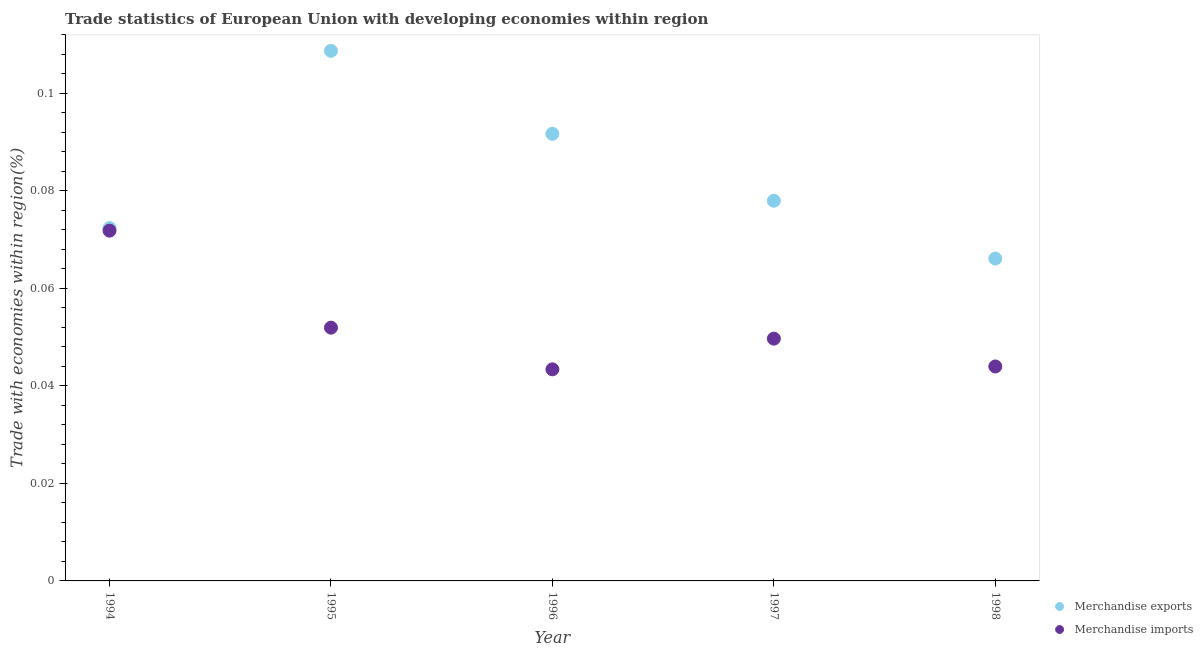How many different coloured dotlines are there?
Your answer should be compact. 2. Is the number of dotlines equal to the number of legend labels?
Your response must be concise. Yes. What is the merchandise exports in 1997?
Provide a short and direct response. 0.08. Across all years, what is the maximum merchandise imports?
Offer a terse response. 0.07. Across all years, what is the minimum merchandise imports?
Offer a very short reply. 0.04. In which year was the merchandise imports maximum?
Give a very brief answer. 1994. What is the total merchandise exports in the graph?
Your response must be concise. 0.42. What is the difference between the merchandise imports in 1997 and that in 1998?
Offer a terse response. 0.01. What is the difference between the merchandise imports in 1994 and the merchandise exports in 1996?
Your answer should be compact. -0.02. What is the average merchandise exports per year?
Offer a very short reply. 0.08. In the year 1997, what is the difference between the merchandise imports and merchandise exports?
Offer a very short reply. -0.03. In how many years, is the merchandise imports greater than 0.048 %?
Your answer should be very brief. 3. What is the ratio of the merchandise exports in 1994 to that in 1998?
Your answer should be very brief. 1.09. Is the difference between the merchandise exports in 1994 and 1997 greater than the difference between the merchandise imports in 1994 and 1997?
Keep it short and to the point. No. What is the difference between the highest and the second highest merchandise imports?
Your answer should be compact. 0.02. What is the difference between the highest and the lowest merchandise imports?
Keep it short and to the point. 0.03. Is the sum of the merchandise imports in 1994 and 1995 greater than the maximum merchandise exports across all years?
Make the answer very short. Yes. How many dotlines are there?
Give a very brief answer. 2. How many years are there in the graph?
Make the answer very short. 5. Does the graph contain any zero values?
Your answer should be very brief. No. Does the graph contain grids?
Ensure brevity in your answer.  No. Where does the legend appear in the graph?
Provide a succinct answer. Bottom right. How are the legend labels stacked?
Offer a terse response. Vertical. What is the title of the graph?
Keep it short and to the point. Trade statistics of European Union with developing economies within region. Does "Depositors" appear as one of the legend labels in the graph?
Your answer should be compact. No. What is the label or title of the X-axis?
Provide a short and direct response. Year. What is the label or title of the Y-axis?
Offer a terse response. Trade with economies within region(%). What is the Trade with economies within region(%) in Merchandise exports in 1994?
Ensure brevity in your answer.  0.07. What is the Trade with economies within region(%) in Merchandise imports in 1994?
Give a very brief answer. 0.07. What is the Trade with economies within region(%) in Merchandise exports in 1995?
Your answer should be compact. 0.11. What is the Trade with economies within region(%) of Merchandise imports in 1995?
Provide a succinct answer. 0.05. What is the Trade with economies within region(%) of Merchandise exports in 1996?
Provide a succinct answer. 0.09. What is the Trade with economies within region(%) of Merchandise imports in 1996?
Keep it short and to the point. 0.04. What is the Trade with economies within region(%) of Merchandise exports in 1997?
Give a very brief answer. 0.08. What is the Trade with economies within region(%) in Merchandise imports in 1997?
Offer a terse response. 0.05. What is the Trade with economies within region(%) of Merchandise exports in 1998?
Offer a terse response. 0.07. What is the Trade with economies within region(%) in Merchandise imports in 1998?
Give a very brief answer. 0.04. Across all years, what is the maximum Trade with economies within region(%) of Merchandise exports?
Offer a terse response. 0.11. Across all years, what is the maximum Trade with economies within region(%) in Merchandise imports?
Provide a short and direct response. 0.07. Across all years, what is the minimum Trade with economies within region(%) of Merchandise exports?
Your answer should be very brief. 0.07. Across all years, what is the minimum Trade with economies within region(%) of Merchandise imports?
Provide a succinct answer. 0.04. What is the total Trade with economies within region(%) in Merchandise exports in the graph?
Provide a succinct answer. 0.42. What is the total Trade with economies within region(%) of Merchandise imports in the graph?
Your answer should be compact. 0.26. What is the difference between the Trade with economies within region(%) in Merchandise exports in 1994 and that in 1995?
Offer a very short reply. -0.04. What is the difference between the Trade with economies within region(%) in Merchandise imports in 1994 and that in 1995?
Offer a very short reply. 0.02. What is the difference between the Trade with economies within region(%) of Merchandise exports in 1994 and that in 1996?
Offer a terse response. -0.02. What is the difference between the Trade with economies within region(%) of Merchandise imports in 1994 and that in 1996?
Your answer should be compact. 0.03. What is the difference between the Trade with economies within region(%) in Merchandise exports in 1994 and that in 1997?
Provide a short and direct response. -0.01. What is the difference between the Trade with economies within region(%) in Merchandise imports in 1994 and that in 1997?
Provide a succinct answer. 0.02. What is the difference between the Trade with economies within region(%) of Merchandise exports in 1994 and that in 1998?
Your response must be concise. 0.01. What is the difference between the Trade with economies within region(%) in Merchandise imports in 1994 and that in 1998?
Your response must be concise. 0.03. What is the difference between the Trade with economies within region(%) of Merchandise exports in 1995 and that in 1996?
Your answer should be very brief. 0.02. What is the difference between the Trade with economies within region(%) in Merchandise imports in 1995 and that in 1996?
Your answer should be very brief. 0.01. What is the difference between the Trade with economies within region(%) of Merchandise exports in 1995 and that in 1997?
Your response must be concise. 0.03. What is the difference between the Trade with economies within region(%) in Merchandise imports in 1995 and that in 1997?
Keep it short and to the point. 0. What is the difference between the Trade with economies within region(%) of Merchandise exports in 1995 and that in 1998?
Give a very brief answer. 0.04. What is the difference between the Trade with economies within region(%) in Merchandise imports in 1995 and that in 1998?
Provide a short and direct response. 0.01. What is the difference between the Trade with economies within region(%) of Merchandise exports in 1996 and that in 1997?
Give a very brief answer. 0.01. What is the difference between the Trade with economies within region(%) of Merchandise imports in 1996 and that in 1997?
Give a very brief answer. -0.01. What is the difference between the Trade with economies within region(%) of Merchandise exports in 1996 and that in 1998?
Your answer should be very brief. 0.03. What is the difference between the Trade with economies within region(%) in Merchandise imports in 1996 and that in 1998?
Your response must be concise. -0. What is the difference between the Trade with economies within region(%) in Merchandise exports in 1997 and that in 1998?
Ensure brevity in your answer.  0.01. What is the difference between the Trade with economies within region(%) in Merchandise imports in 1997 and that in 1998?
Your answer should be compact. 0.01. What is the difference between the Trade with economies within region(%) in Merchandise exports in 1994 and the Trade with economies within region(%) in Merchandise imports in 1995?
Your answer should be compact. 0.02. What is the difference between the Trade with economies within region(%) in Merchandise exports in 1994 and the Trade with economies within region(%) in Merchandise imports in 1996?
Provide a short and direct response. 0.03. What is the difference between the Trade with economies within region(%) of Merchandise exports in 1994 and the Trade with economies within region(%) of Merchandise imports in 1997?
Your answer should be compact. 0.02. What is the difference between the Trade with economies within region(%) of Merchandise exports in 1994 and the Trade with economies within region(%) of Merchandise imports in 1998?
Offer a terse response. 0.03. What is the difference between the Trade with economies within region(%) in Merchandise exports in 1995 and the Trade with economies within region(%) in Merchandise imports in 1996?
Keep it short and to the point. 0.07. What is the difference between the Trade with economies within region(%) in Merchandise exports in 1995 and the Trade with economies within region(%) in Merchandise imports in 1997?
Offer a very short reply. 0.06. What is the difference between the Trade with economies within region(%) of Merchandise exports in 1995 and the Trade with economies within region(%) of Merchandise imports in 1998?
Give a very brief answer. 0.06. What is the difference between the Trade with economies within region(%) in Merchandise exports in 1996 and the Trade with economies within region(%) in Merchandise imports in 1997?
Your response must be concise. 0.04. What is the difference between the Trade with economies within region(%) of Merchandise exports in 1996 and the Trade with economies within region(%) of Merchandise imports in 1998?
Provide a succinct answer. 0.05. What is the difference between the Trade with economies within region(%) of Merchandise exports in 1997 and the Trade with economies within region(%) of Merchandise imports in 1998?
Make the answer very short. 0.03. What is the average Trade with economies within region(%) in Merchandise exports per year?
Offer a terse response. 0.08. What is the average Trade with economies within region(%) in Merchandise imports per year?
Offer a terse response. 0.05. In the year 1995, what is the difference between the Trade with economies within region(%) in Merchandise exports and Trade with economies within region(%) in Merchandise imports?
Your answer should be compact. 0.06. In the year 1996, what is the difference between the Trade with economies within region(%) of Merchandise exports and Trade with economies within region(%) of Merchandise imports?
Offer a terse response. 0.05. In the year 1997, what is the difference between the Trade with economies within region(%) in Merchandise exports and Trade with economies within region(%) in Merchandise imports?
Ensure brevity in your answer.  0.03. In the year 1998, what is the difference between the Trade with economies within region(%) in Merchandise exports and Trade with economies within region(%) in Merchandise imports?
Your answer should be very brief. 0.02. What is the ratio of the Trade with economies within region(%) in Merchandise exports in 1994 to that in 1995?
Your response must be concise. 0.67. What is the ratio of the Trade with economies within region(%) in Merchandise imports in 1994 to that in 1995?
Provide a succinct answer. 1.38. What is the ratio of the Trade with economies within region(%) of Merchandise exports in 1994 to that in 1996?
Keep it short and to the point. 0.79. What is the ratio of the Trade with economies within region(%) of Merchandise imports in 1994 to that in 1996?
Offer a terse response. 1.66. What is the ratio of the Trade with economies within region(%) of Merchandise exports in 1994 to that in 1997?
Provide a succinct answer. 0.93. What is the ratio of the Trade with economies within region(%) in Merchandise imports in 1994 to that in 1997?
Your answer should be compact. 1.45. What is the ratio of the Trade with economies within region(%) of Merchandise exports in 1994 to that in 1998?
Ensure brevity in your answer.  1.09. What is the ratio of the Trade with economies within region(%) in Merchandise imports in 1994 to that in 1998?
Your answer should be compact. 1.63. What is the ratio of the Trade with economies within region(%) in Merchandise exports in 1995 to that in 1996?
Make the answer very short. 1.19. What is the ratio of the Trade with economies within region(%) in Merchandise imports in 1995 to that in 1996?
Make the answer very short. 1.2. What is the ratio of the Trade with economies within region(%) of Merchandise exports in 1995 to that in 1997?
Make the answer very short. 1.39. What is the ratio of the Trade with economies within region(%) of Merchandise imports in 1995 to that in 1997?
Your response must be concise. 1.05. What is the ratio of the Trade with economies within region(%) in Merchandise exports in 1995 to that in 1998?
Your answer should be compact. 1.64. What is the ratio of the Trade with economies within region(%) of Merchandise imports in 1995 to that in 1998?
Your response must be concise. 1.18. What is the ratio of the Trade with economies within region(%) of Merchandise exports in 1996 to that in 1997?
Your answer should be compact. 1.18. What is the ratio of the Trade with economies within region(%) of Merchandise imports in 1996 to that in 1997?
Make the answer very short. 0.87. What is the ratio of the Trade with economies within region(%) in Merchandise exports in 1996 to that in 1998?
Offer a very short reply. 1.39. What is the ratio of the Trade with economies within region(%) of Merchandise imports in 1996 to that in 1998?
Provide a short and direct response. 0.99. What is the ratio of the Trade with economies within region(%) of Merchandise exports in 1997 to that in 1998?
Your answer should be compact. 1.18. What is the ratio of the Trade with economies within region(%) of Merchandise imports in 1997 to that in 1998?
Give a very brief answer. 1.13. What is the difference between the highest and the second highest Trade with economies within region(%) in Merchandise exports?
Your answer should be very brief. 0.02. What is the difference between the highest and the second highest Trade with economies within region(%) in Merchandise imports?
Offer a very short reply. 0.02. What is the difference between the highest and the lowest Trade with economies within region(%) in Merchandise exports?
Make the answer very short. 0.04. What is the difference between the highest and the lowest Trade with economies within region(%) of Merchandise imports?
Offer a terse response. 0.03. 